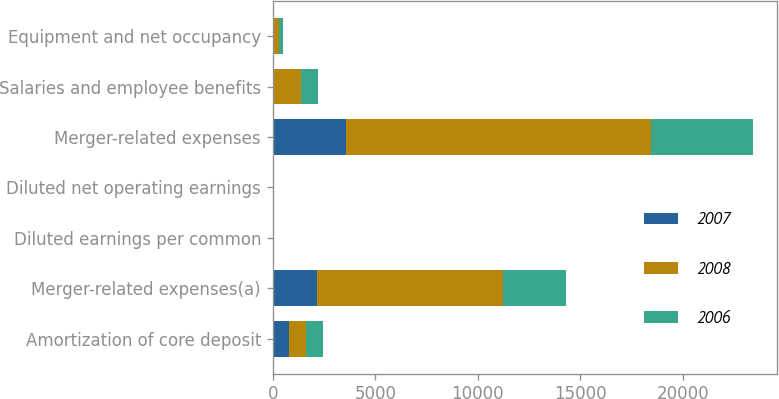Convert chart to OTSL. <chart><loc_0><loc_0><loc_500><loc_500><stacked_bar_chart><ecel><fcel>Amortization of core deposit<fcel>Merger-related expenses(a)<fcel>Diluted earnings per common<fcel>Diluted net operating earnings<fcel>Merger-related expenses<fcel>Salaries and employee benefits<fcel>Equipment and net occupancy<nl><fcel>2007<fcel>815<fcel>2160<fcel>5.01<fcel>5.39<fcel>3547<fcel>62<fcel>49<nl><fcel>2008<fcel>815<fcel>9070<fcel>5.95<fcel>6.4<fcel>14887<fcel>1333<fcel>238<nl><fcel>2006<fcel>815<fcel>3048<fcel>7.37<fcel>7.73<fcel>4997<fcel>815<fcel>224<nl></chart> 